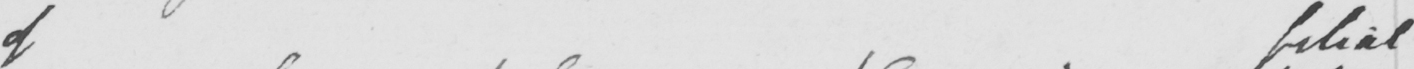Can you read and transcribe this handwriting? of filial 